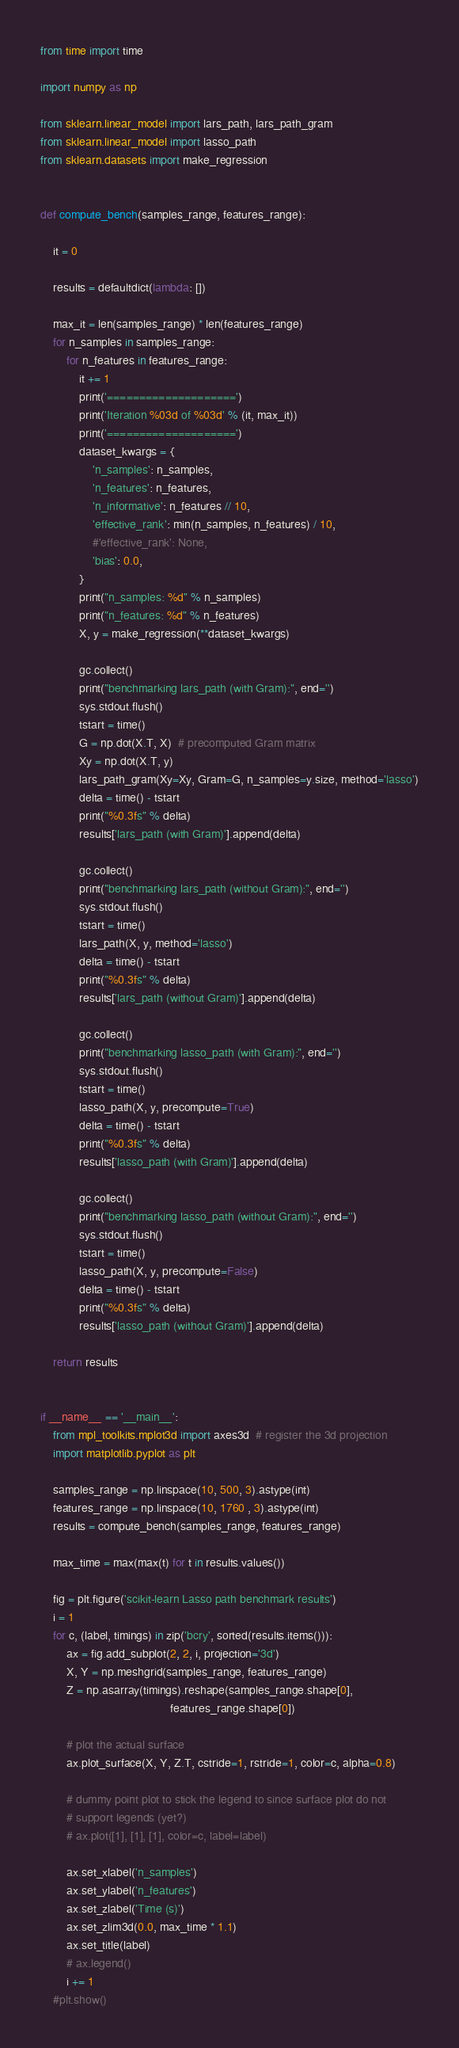Convert code to text. <code><loc_0><loc_0><loc_500><loc_500><_Python_>from time import time

import numpy as np

from sklearn.linear_model import lars_path, lars_path_gram
from sklearn.linear_model import lasso_path
from sklearn.datasets import make_regression


def compute_bench(samples_range, features_range):

    it = 0

    results = defaultdict(lambda: [])

    max_it = len(samples_range) * len(features_range)
    for n_samples in samples_range:
        for n_features in features_range:
            it += 1
            print('====================')
            print('Iteration %03d of %03d' % (it, max_it))
            print('====================')
            dataset_kwargs = {
                'n_samples': n_samples,
                'n_features': n_features,
                'n_informative': n_features // 10,
                'effective_rank': min(n_samples, n_features) / 10,
                #'effective_rank': None,
                'bias': 0.0,
            }
            print("n_samples: %d" % n_samples)
            print("n_features: %d" % n_features)
            X, y = make_regression(**dataset_kwargs)

            gc.collect()
            print("benchmarking lars_path (with Gram):", end='')
            sys.stdout.flush()
            tstart = time()
            G = np.dot(X.T, X)  # precomputed Gram matrix
            Xy = np.dot(X.T, y)
            lars_path_gram(Xy=Xy, Gram=G, n_samples=y.size, method='lasso')
            delta = time() - tstart
            print("%0.3fs" % delta)
            results['lars_path (with Gram)'].append(delta)

            gc.collect()
            print("benchmarking lars_path (without Gram):", end='')
            sys.stdout.flush()
            tstart = time()
            lars_path(X, y, method='lasso')
            delta = time() - tstart
            print("%0.3fs" % delta)
            results['lars_path (without Gram)'].append(delta)

            gc.collect()
            print("benchmarking lasso_path (with Gram):", end='')
            sys.stdout.flush()
            tstart = time()
            lasso_path(X, y, precompute=True)
            delta = time() - tstart
            print("%0.3fs" % delta)
            results['lasso_path (with Gram)'].append(delta)

            gc.collect()
            print("benchmarking lasso_path (without Gram):", end='')
            sys.stdout.flush()
            tstart = time()
            lasso_path(X, y, precompute=False)
            delta = time() - tstart
            print("%0.3fs" % delta)
            results['lasso_path (without Gram)'].append(delta)

    return results


if __name__ == '__main__':
    from mpl_toolkits.mplot3d import axes3d  # register the 3d projection
    import matplotlib.pyplot as plt

    samples_range = np.linspace(10, 500, 3).astype(int) 
    features_range = np.linspace(10, 1760 , 3).astype(int) 
    results = compute_bench(samples_range, features_range)

    max_time = max(max(t) for t in results.values())

    fig = plt.figure('scikit-learn Lasso path benchmark results')
    i = 1
    for c, (label, timings) in zip('bcry', sorted(results.items())):
        ax = fig.add_subplot(2, 2, i, projection='3d')
        X, Y = np.meshgrid(samples_range, features_range)
        Z = np.asarray(timings).reshape(samples_range.shape[0],
                                        features_range.shape[0])

        # plot the actual surface
        ax.plot_surface(X, Y, Z.T, cstride=1, rstride=1, color=c, alpha=0.8)

        # dummy point plot to stick the legend to since surface plot do not
        # support legends (yet?)
        # ax.plot([1], [1], [1], color=c, label=label)

        ax.set_xlabel('n_samples')
        ax.set_ylabel('n_features')
        ax.set_zlabel('Time (s)')
        ax.set_zlim3d(0.0, max_time * 1.1)
        ax.set_title(label)
        # ax.legend()
        i += 1
    #plt.show()
</code> 